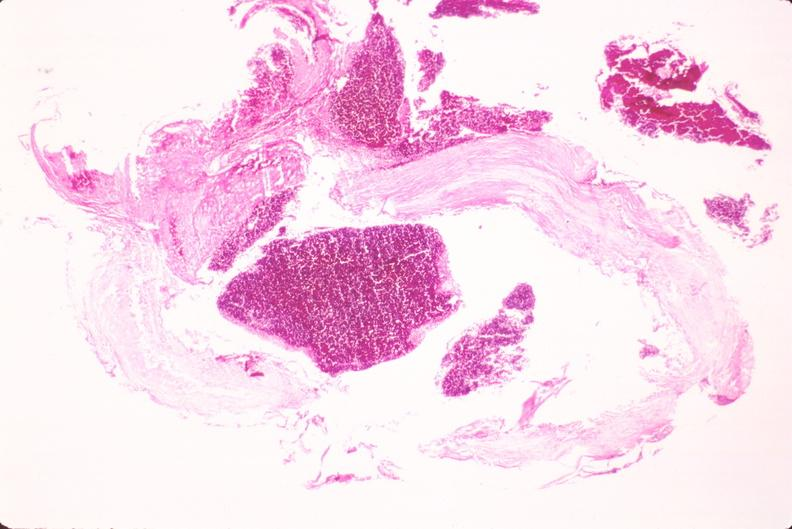what does this image show?
Answer the question using a single word or phrase. Ruptured saccular aneurysm right middle cerebral artery 